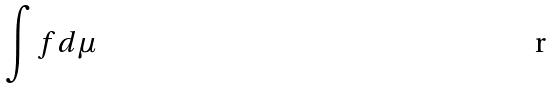Convert formula to latex. <formula><loc_0><loc_0><loc_500><loc_500>\int f d \mu</formula> 